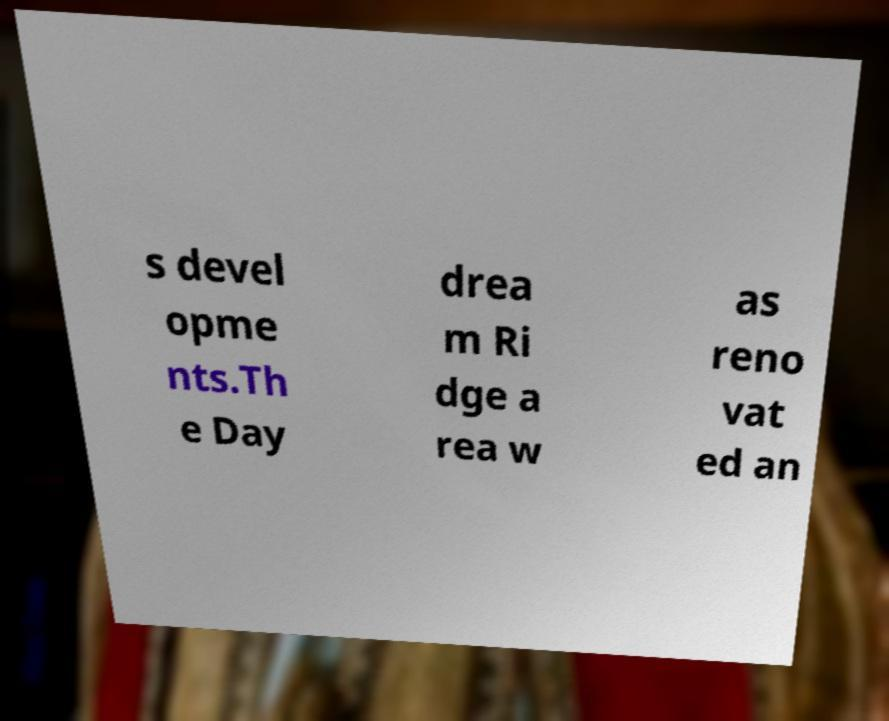Can you read and provide the text displayed in the image?This photo seems to have some interesting text. Can you extract and type it out for me? s devel opme nts.Th e Day drea m Ri dge a rea w as reno vat ed an 